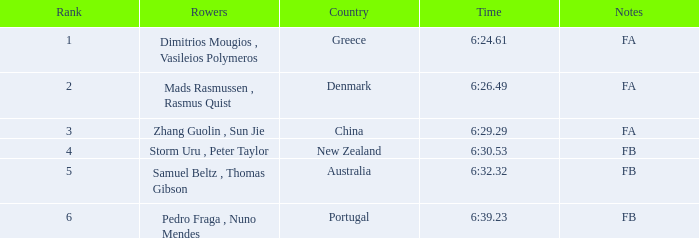Which country possesses a rank under 6, a time span of 6:3 Australia. 